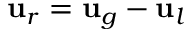Convert formula to latex. <formula><loc_0><loc_0><loc_500><loc_500>u _ { r } = u _ { g } - u _ { l }</formula> 